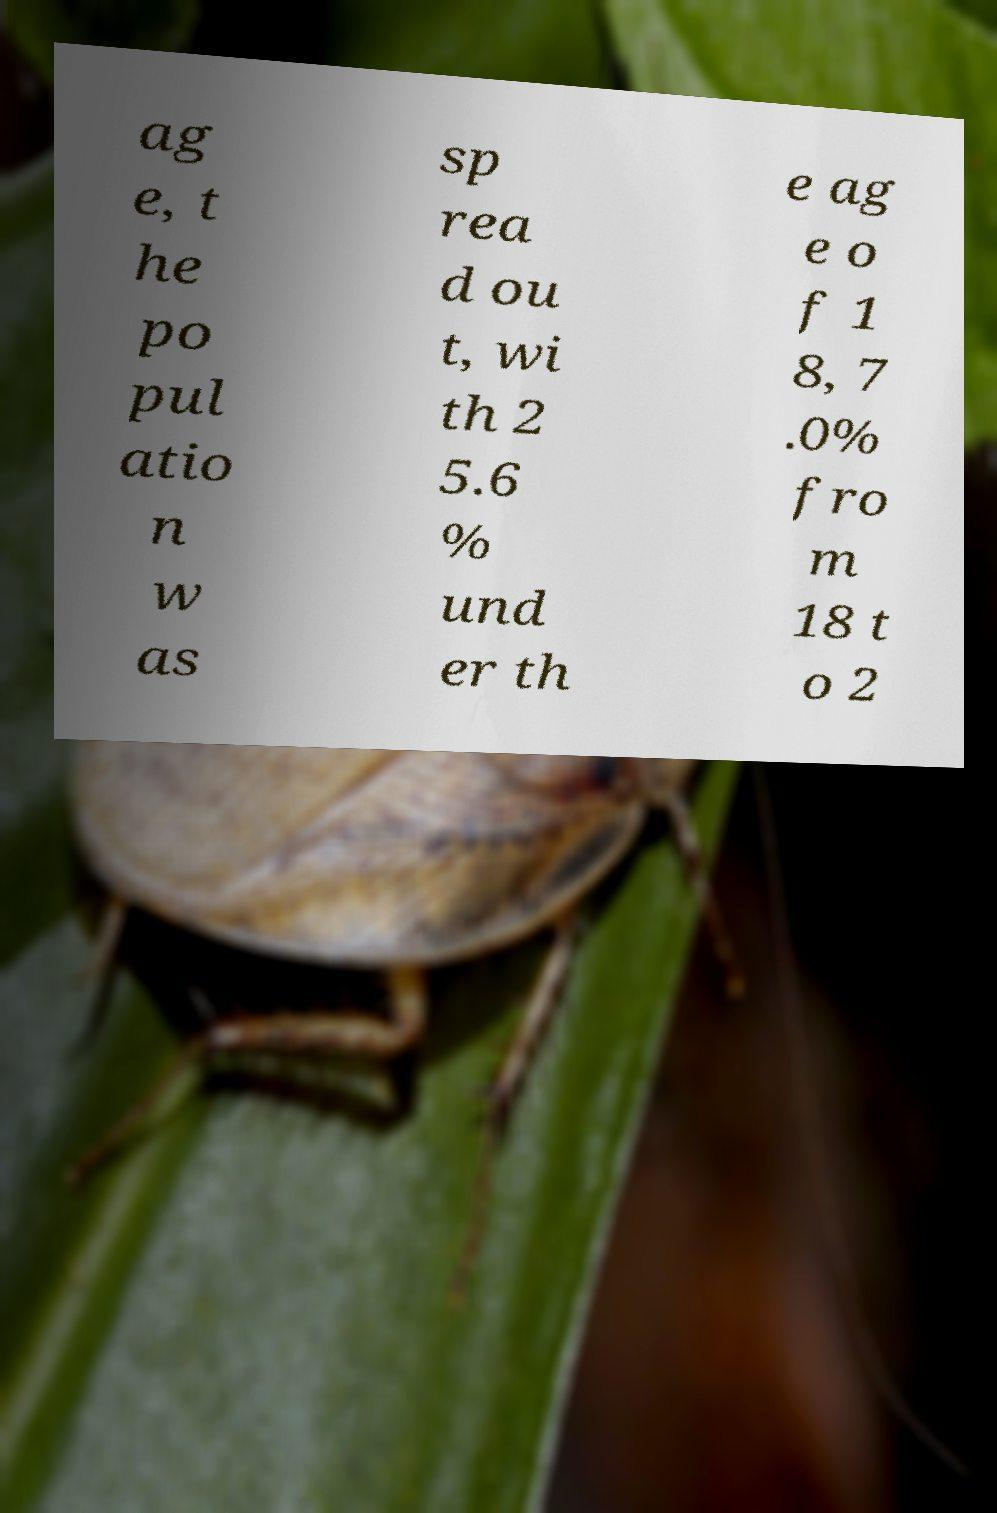Please read and relay the text visible in this image. What does it say? ag e, t he po pul atio n w as sp rea d ou t, wi th 2 5.6 % und er th e ag e o f 1 8, 7 .0% fro m 18 t o 2 